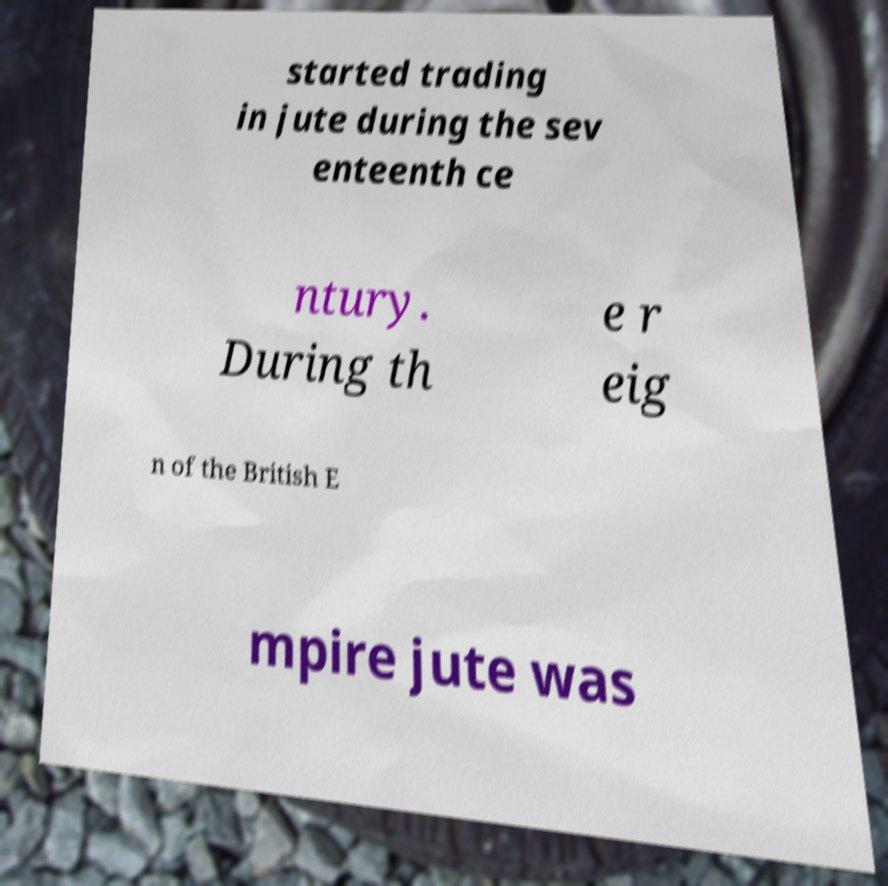Please identify and transcribe the text found in this image. started trading in jute during the sev enteenth ce ntury. During th e r eig n of the British E mpire jute was 